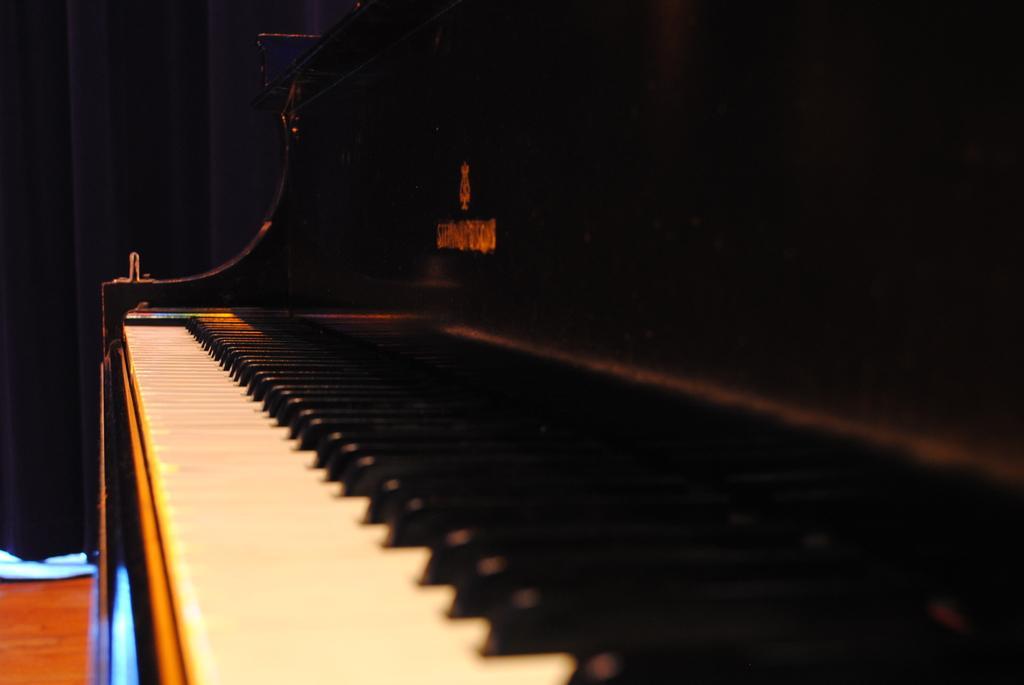Can you describe this image briefly? This image consists of a keyboard. There are white keys and black keys. This is a musical instrument. There is a curtain on the right, left side top corner, it is in black color. 